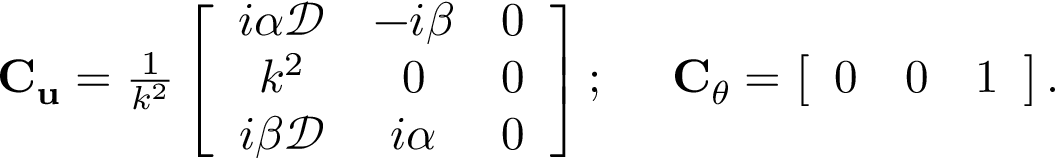Convert formula to latex. <formula><loc_0><loc_0><loc_500><loc_500>\begin{array} { r } { C _ { u } = \frac { 1 } { k ^ { 2 } } \left [ \begin{array} { c c c } { i \alpha \mathcal { D } } & { - i \beta } & { 0 } \\ { k ^ { 2 } } & { 0 } & { 0 } \\ { i \beta \mathcal { D } } & { i \alpha } & { 0 } \end{array} \right ] ; C _ { \theta } = \left [ \begin{array} { c c c } { 0 } & { 0 } & { 1 } \end{array} \right ] . } \end{array}</formula> 